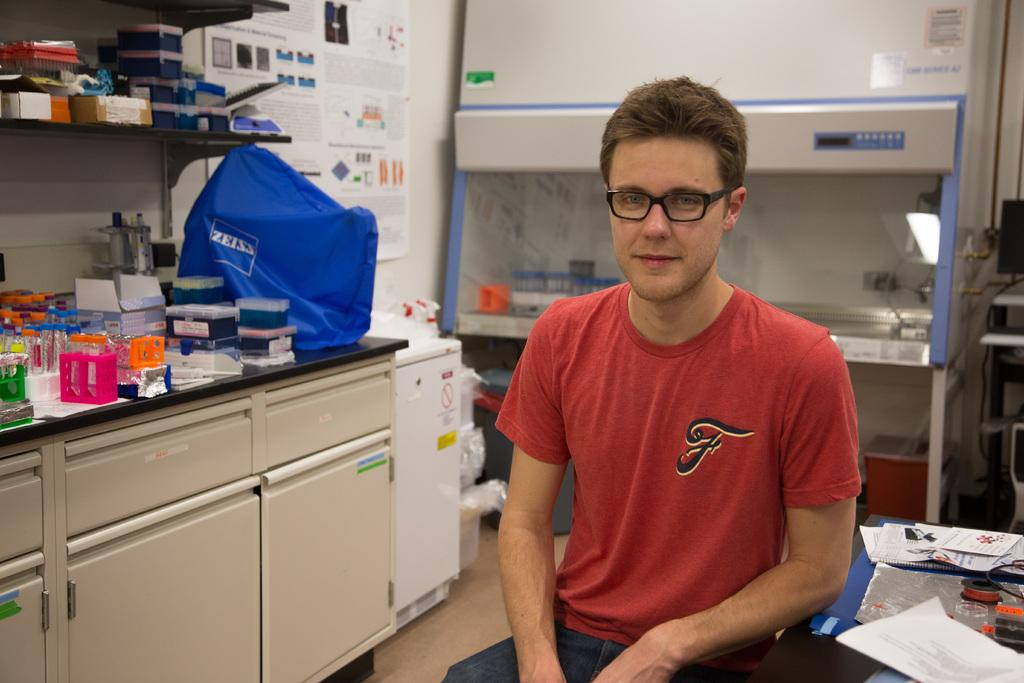<image>
Present a compact description of the photo's key features. A man in a red shirt is sitting in a lab by a counter with a blue package on it that says Zeiss. 